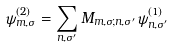<formula> <loc_0><loc_0><loc_500><loc_500>\psi ^ { ( 2 ) } _ { m , \sigma } = \sum _ { n , \sigma ^ { \prime } } M _ { m , \sigma ; n , \sigma ^ { \prime } } \psi ^ { ( 1 ) } _ { n , \sigma ^ { \prime } }</formula> 